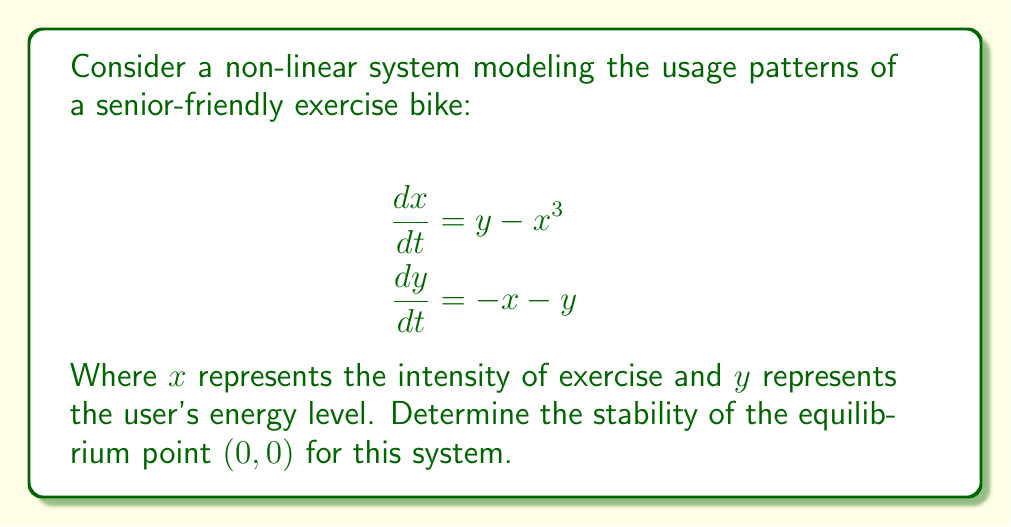Give your solution to this math problem. To analyze the stability of the equilibrium point $(0,0)$, we'll follow these steps:

1) First, we need to find the Jacobian matrix of the system at the equilibrium point:

   $$J = \begin{bmatrix}
   \frac{\partial f_1}{\partial x} & \frac{\partial f_1}{\partial y} \\
   \frac{\partial f_2}{\partial x} & \frac{\partial f_2}{\partial y}
   \end{bmatrix}$$

   Where $f_1 = y - x^3$ and $f_2 = -x - y$

2) Calculate the partial derivatives:
   
   $\frac{\partial f_1}{\partial x} = -3x^2$
   $\frac{\partial f_1}{\partial y} = 1$
   $\frac{\partial f_2}{\partial x} = -1$
   $\frac{\partial f_2}{\partial y} = -1$

3) Evaluate the Jacobian at the equilibrium point $(0,0)$:

   $$J_{(0,0)} = \begin{bmatrix}
   0 & 1 \\
   -1 & -1
   \end{bmatrix}$$

4) Find the eigenvalues of $J_{(0,0)}$ by solving the characteristic equation:

   $$\det(J_{(0,0)} - \lambda I) = 0$$
   
   $$\begin{vmatrix}
   -\lambda & 1 \\
   -1 & -1-\lambda
   \end{vmatrix} = 0$$
   
   $$\lambda^2 + \lambda + 1 = 0$$

5) Solve this quadratic equation:

   $$\lambda = \frac{-1 \pm \sqrt{1^2 - 4(1)(1)}}{2(1)} = \frac{-1 \pm \sqrt{-3}}{2}$$

6) The eigenvalues are complex conjugates with negative real parts:

   $$\lambda_1 = -\frac{1}{2} + i\frac{\sqrt{3}}{2}$$
   $$\lambda_2 = -\frac{1}{2} - i\frac{\sqrt{3}}{2}$$

7) Since both eigenvalues have negative real parts, the equilibrium point $(0,0)$ is asymptotically stable.
Answer: Asymptotically stable 